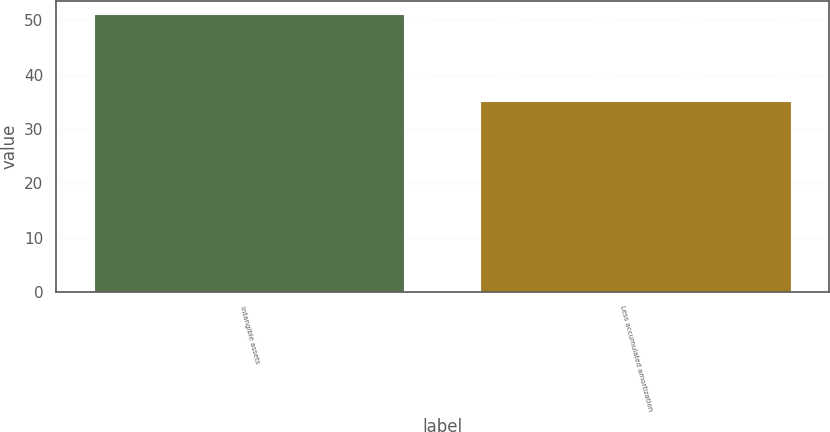<chart> <loc_0><loc_0><loc_500><loc_500><bar_chart><fcel>Intangible assets<fcel>Less accumulated amortization<nl><fcel>51<fcel>35<nl></chart> 